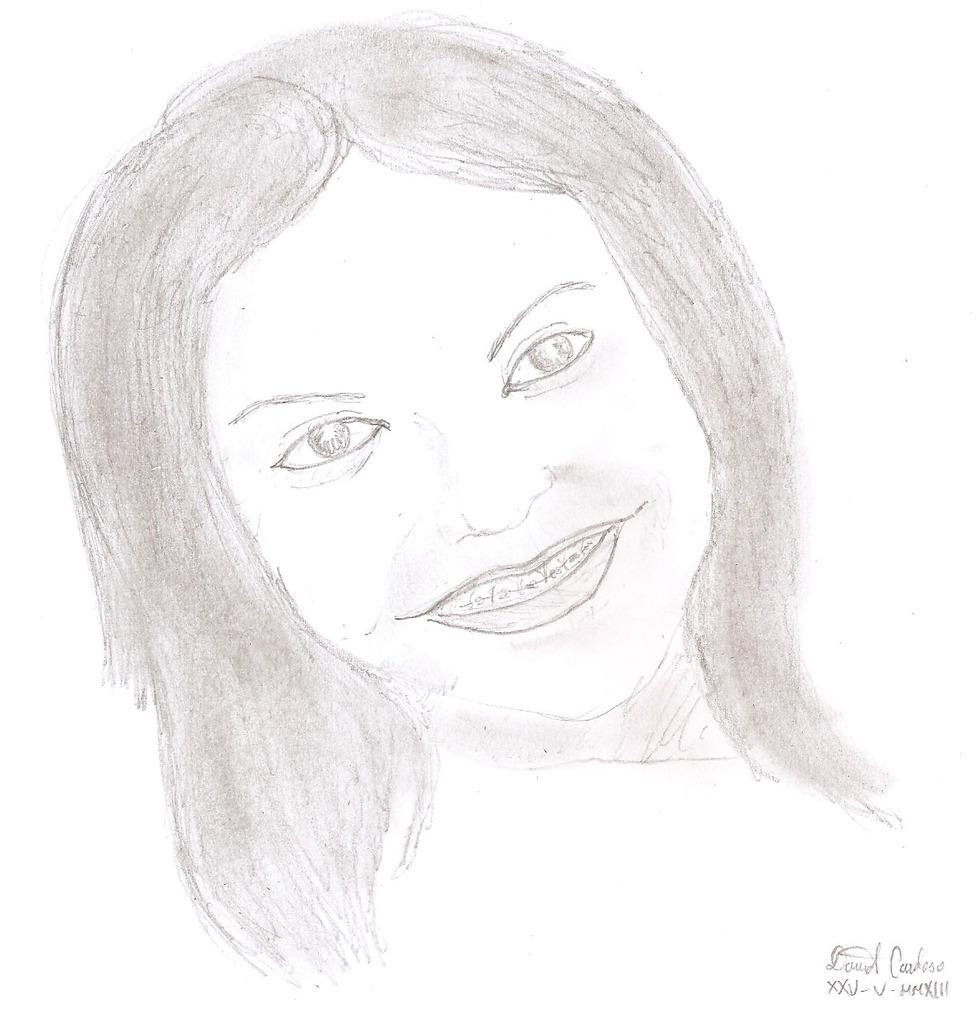What is the main subject of the image? The main subject of the image is a sketch of a lady. Is there any text associated with the image? Yes, there is text at the bottom of the image. What type of animal is providing shade for the lady in the image? There is no animal present in the image, and the lady is not being provided shade by any animal. 